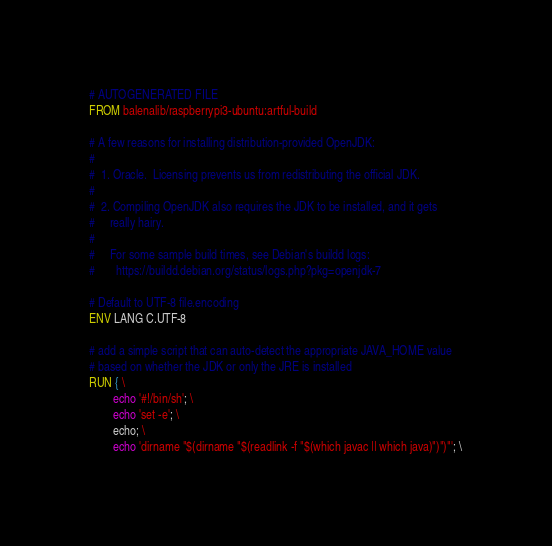<code> <loc_0><loc_0><loc_500><loc_500><_Dockerfile_># AUTOGENERATED FILE
FROM balenalib/raspberrypi3-ubuntu:artful-build

# A few reasons for installing distribution-provided OpenJDK:
#
#  1. Oracle.  Licensing prevents us from redistributing the official JDK.
#
#  2. Compiling OpenJDK also requires the JDK to be installed, and it gets
#     really hairy.
#
#     For some sample build times, see Debian's buildd logs:
#       https://buildd.debian.org/status/logs.php?pkg=openjdk-7

# Default to UTF-8 file.encoding
ENV LANG C.UTF-8

# add a simple script that can auto-detect the appropriate JAVA_HOME value
# based on whether the JDK or only the JRE is installed
RUN { \
		echo '#!/bin/sh'; \
		echo 'set -e'; \
		echo; \
		echo 'dirname "$(dirname "$(readlink -f "$(which javac || which java)")")"'; \</code> 